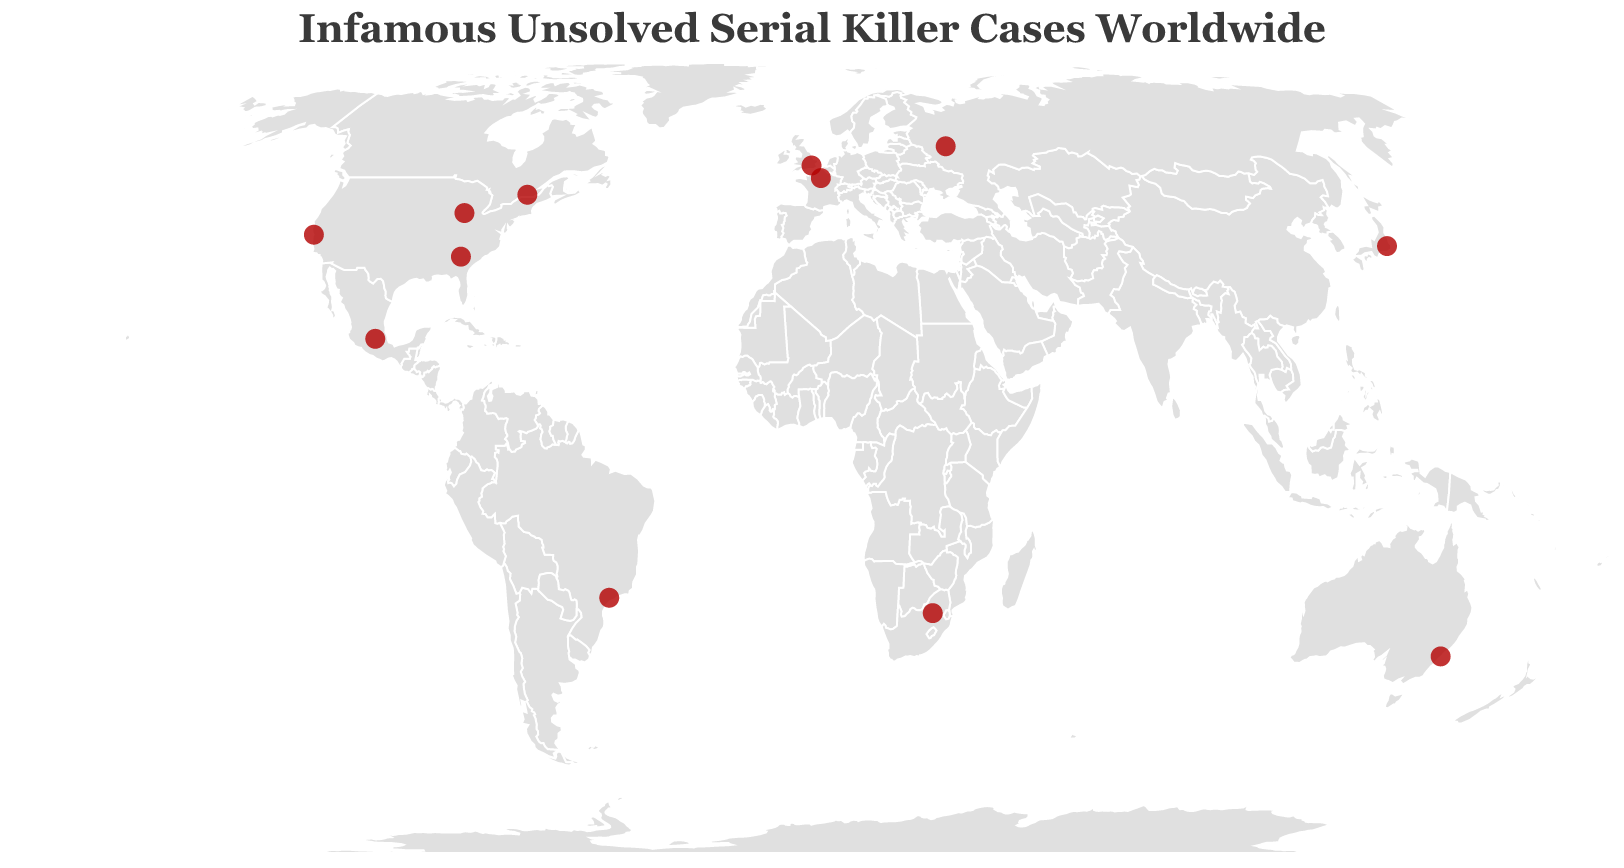Who are some of the infamous unsolved serial killers shown on the map? Some of the infamous unsolved serial killers on the map include Jack the Ripper in London, the Zodiac Killer in San Francisco, and the Monster of Florence in Italy.
Answer: Jack the Ripper, Zodiac Killer, Monster of Florence Which serial killer case happened the earliest, and where? The case that happened the earliest is the Jack the Ripper case, which took place in London, UK, in 1888.
Answer: Jack the Ripper, London UK, 1888 How many total unsolved serial killer cases are shown on the map? Counting the circles (data points) on the map, we see there are a total of 12 unsolved serial killer cases depicted.
Answer: 12 Which cases occurred in the United States and in which cities? The cases in the United States include the Zodiac Killer in San Francisco, Atlanta Child Murders in Atlanta, and the Chicago Tylenol Murders in Chicago.
Answer: Zodiac Killer in San Francisco, Atlanta Child Murders in Atlanta, Chicago Tylenol Murders in Chicago What is the latest year in which an unsolved serial killer case occurred according to the map? The latest year for an unsolved serial killer case on the map is 2010, which corresponds to the ABC Killer case in Johannesburg, South Africa.
Answer: 2010, ABC Killer, Johannesburg Which continents have more than one unsolved serial killer case and which cases are they? North America has more than one unsolved case: Zodiac Killer in San Francisco, Atlanta Child Murders in Atlanta, Chicago Tylenol Murders in Chicago, and The Montreal Vampire in Montreal.
Answer: North America, Zodiac Killer, Atlanta Child Murders, Chicago Tylenol Murders, The Montreal Vampire Which unsolved serial killer case is closest to the equator? The closest unsolved serial killer case to the equator is the Rainbow Maniac case in Sao Paulo, Brazil.
Answer: Rainbow Maniac Between the Wanda Beach Murders and the ABC Killer, which one happened more recently and by how many years? The ABC Killer occurred more recently than the Wanda Beach Murders by 45 years (2010 - 1965 = 45 years).
Answer: ABC Killer, 45 years Which case is geographically the furthest north, and which is the furthest south? The furthest north case is the Bitsa Park Maniac in Moscow, Russia, and the furthest south case is the Wanda Beach Murders in Sydney, Australia.
Answer: Bitsa Park Maniac in Moscow, Wanda Beach Murders in Sydney 